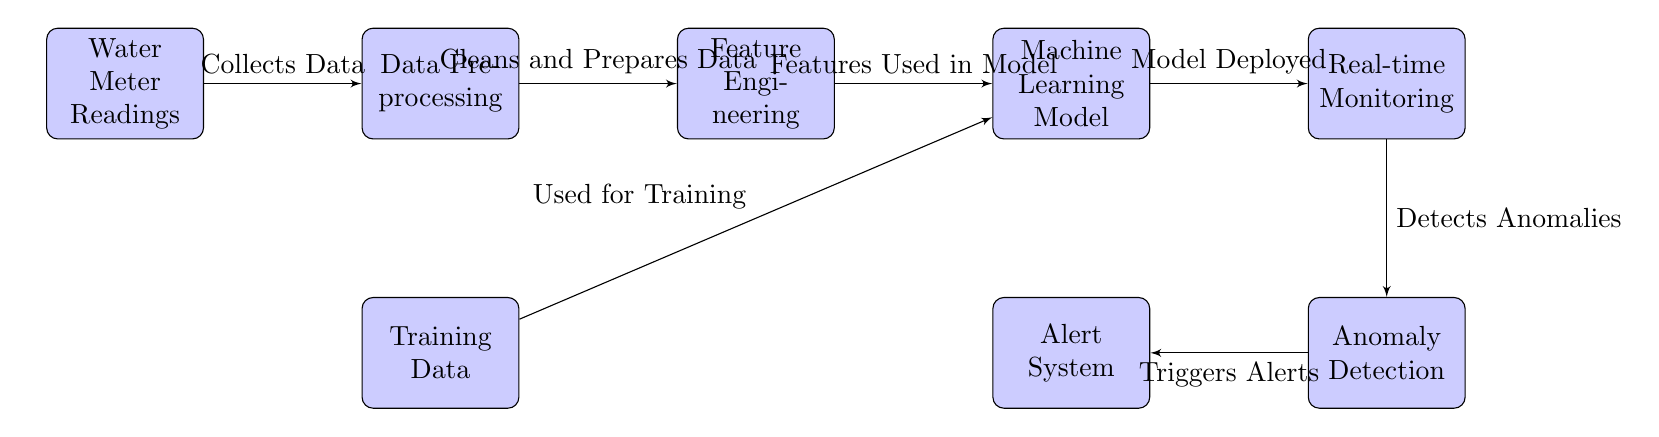What's the total number of nodes in this diagram? The diagram contains eight blocks, which represent the various steps in the process of identifying anomalies in water usage. Counting them gives us a total of eight nodes.
Answer: 8 What type of data is collected by the first node? The first node is labeled "Water Meter Readings," indicating that it collects data pertaining to the water usage measured by the water meters.
Answer: Water Meter Readings Which node is responsible for cleaning and preparing the data? The node that follows the "Water Meter Readings" node is labeled "Data Preprocessing." This indicates its function to clean and prepare the data for further analysis.
Answer: Data Preprocessing What follows after the "Machine Learning Model" node? After the "Machine Learning Model" node, the next step indicated by the diagram is "Real-time Monitoring," highlighting the immediate application of the trained model.
Answer: Real-time Monitoring How many edges connect the "Real-time Monitoring" node to other nodes? The "Real-time Monitoring" node connects to two other nodes: "Machine Learning Model" and "Anomaly Detection," which directly link it to subsequent actions in the process.
Answer: 2 What triggers the alerts in this process? The alerts are triggered by the "Anomaly Detection" node, which is designed to detect unexpected patterns in the data and subsequently initiate alerts through its subsequent connection to the "Alert System."
Answer: Anomaly Detection What is the main purpose of the diagram? The overall purpose of the diagram depicts a process aimed at identifying anomalies in water usage for leak detection and prevention, illustrating the various stages and their interconnections.
Answer: Identifying Anomalies in Water Usage What distinct process occurs within the "Feature Engineering" node? The "Feature Engineering" node is responsible for deriving features utilized in the machine learning model, which is crucial for improving the model's performance on the task.
Answer: Features Used in Model From which nodes is the "Training Data" taken? "Training Data" is derived from the "Data Preprocessing" node and is also utilized in the "Machine Learning Model" for training purposes, implying it serves multiple roles in the machine learning workflow.
Answer: Data Preprocessing, Machine Learning Model 